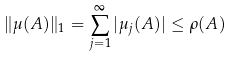<formula> <loc_0><loc_0><loc_500><loc_500>\| \mu ( A ) \| _ { 1 } = \sum _ { j = 1 } ^ { \infty } | \mu _ { j } ( A ) | \leq \rho ( A )</formula> 